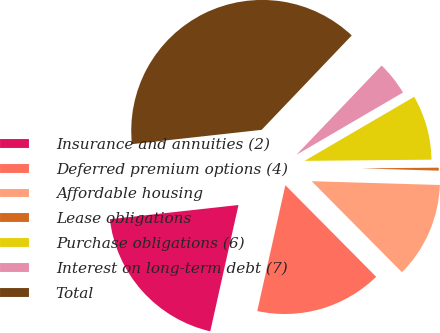Convert chart. <chart><loc_0><loc_0><loc_500><loc_500><pie_chart><fcel>Insurance and annuities (2)<fcel>Deferred premium options (4)<fcel>Affordable housing<fcel>Lease obligations<fcel>Purchase obligations (6)<fcel>Interest on long-term debt (7)<fcel>Total<nl><fcel>19.75%<fcel>15.93%<fcel>12.1%<fcel>0.62%<fcel>8.27%<fcel>4.45%<fcel>38.88%<nl></chart> 